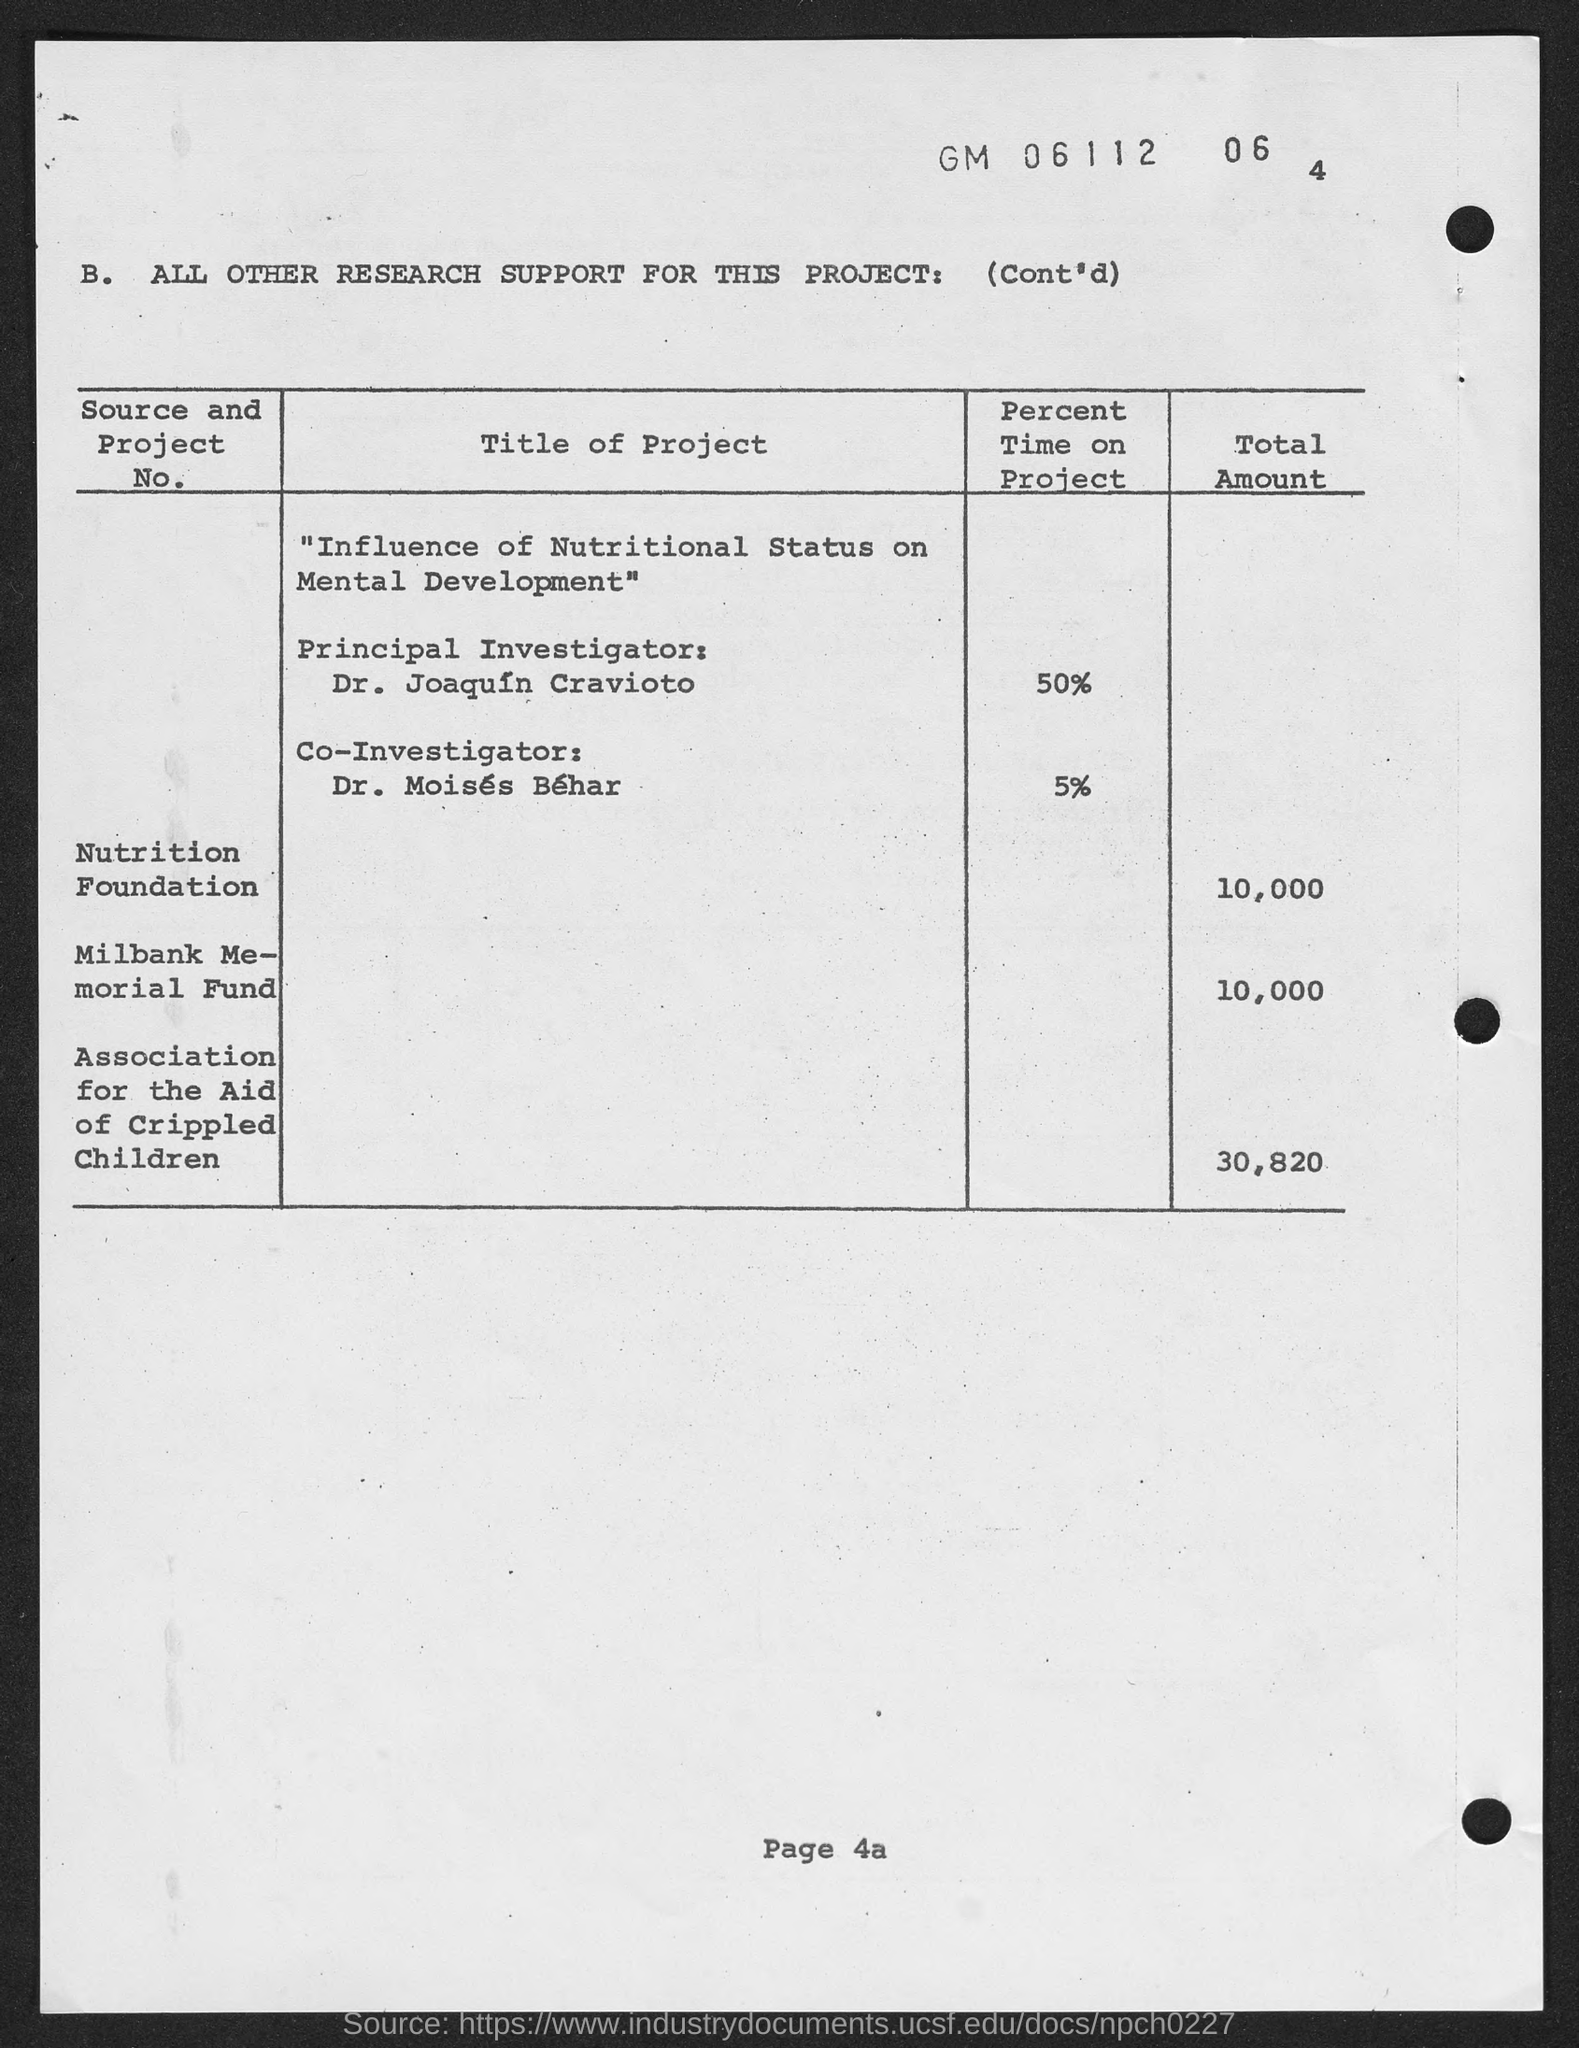What is the page no mentioned in this document?
Offer a very short reply. 4a. Who is the Principal Investigator for the project titled  'Influence of Nutritional Status on Mental Development'?
Your response must be concise. Dr. Joaquin Cravioto. What percent of time is devoted by Dr. Joaquin Cravioto for this project?
Give a very brief answer. 50%. Who is the Co-Investigator for the project titled 'Influence of Nutritional Status on Mental Development'?
Ensure brevity in your answer.  Dr. Moises Behar. What percent of time is devoted by Dr. Moises Behar for this project?
Your answer should be very brief. 5%. What is the title of the project given in the document?
Provide a succinct answer. "Influence of Nutritional Status on Mental Development". What is the total amount funded by Nutrition Foundation for this project?
Keep it short and to the point. 10,000. What is the total amount funded by Association for the Aid of Crippled Children for this project?
Make the answer very short. 30,820. What is the total amount funded by Milbank Memorial Fund for this project?
Provide a succinct answer. 10,000. 